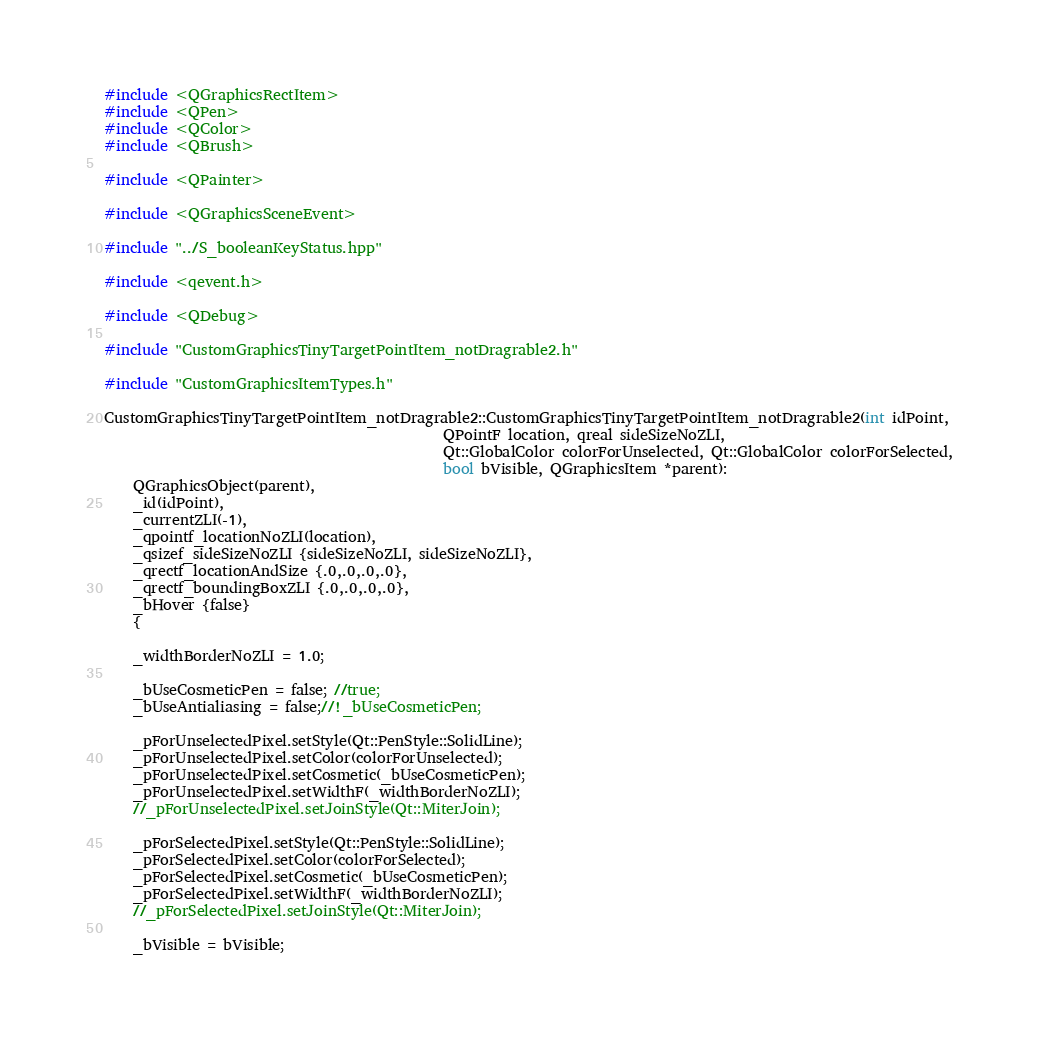Convert code to text. <code><loc_0><loc_0><loc_500><loc_500><_C++_>#include <QGraphicsRectItem>
#include <QPen>
#include <QColor>
#include <QBrush>

#include <QPainter>

#include <QGraphicsSceneEvent>

#include "../S_booleanKeyStatus.hpp"

#include <qevent.h>

#include <QDebug>

#include "CustomGraphicsTinyTargetPointItem_notDragrable2.h"

#include "CustomGraphicsItemTypes.h"

CustomGraphicsTinyTargetPointItem_notDragrable2::CustomGraphicsTinyTargetPointItem_notDragrable2(int idPoint,
                                               QPointF location, qreal sideSizeNoZLI,
                                               Qt::GlobalColor colorForUnselected, Qt::GlobalColor colorForSelected,
                                               bool bVisible, QGraphicsItem *parent):
    QGraphicsObject(parent),
    _id(idPoint),
    _currentZLI(-1),
    _qpointf_locationNoZLI(location),
    _qsizef_sideSizeNoZLI {sideSizeNoZLI, sideSizeNoZLI},
    _qrectf_locationAndSize {.0,.0,.0,.0},
    _qrectf_boundingBoxZLI {.0,.0,.0,.0},
    _bHover {false}
    {

    _widthBorderNoZLI = 1.0;

    _bUseCosmeticPen = false; //true;
    _bUseAntialiasing = false;//!_bUseCosmeticPen;

    _pForUnselectedPixel.setStyle(Qt::PenStyle::SolidLine);
    _pForUnselectedPixel.setColor(colorForUnselected);
    _pForUnselectedPixel.setCosmetic(_bUseCosmeticPen);
    _pForUnselectedPixel.setWidthF(_widthBorderNoZLI);
    //_pForUnselectedPixel.setJoinStyle(Qt::MiterJoin);

    _pForSelectedPixel.setStyle(Qt::PenStyle::SolidLine);
    _pForSelectedPixel.setColor(colorForSelected);
    _pForSelectedPixel.setCosmetic(_bUseCosmeticPen);
    _pForSelectedPixel.setWidthF(_widthBorderNoZLI);
    //_pForSelectedPixel.setJoinStyle(Qt::MiterJoin);

    _bVisible = bVisible;</code> 